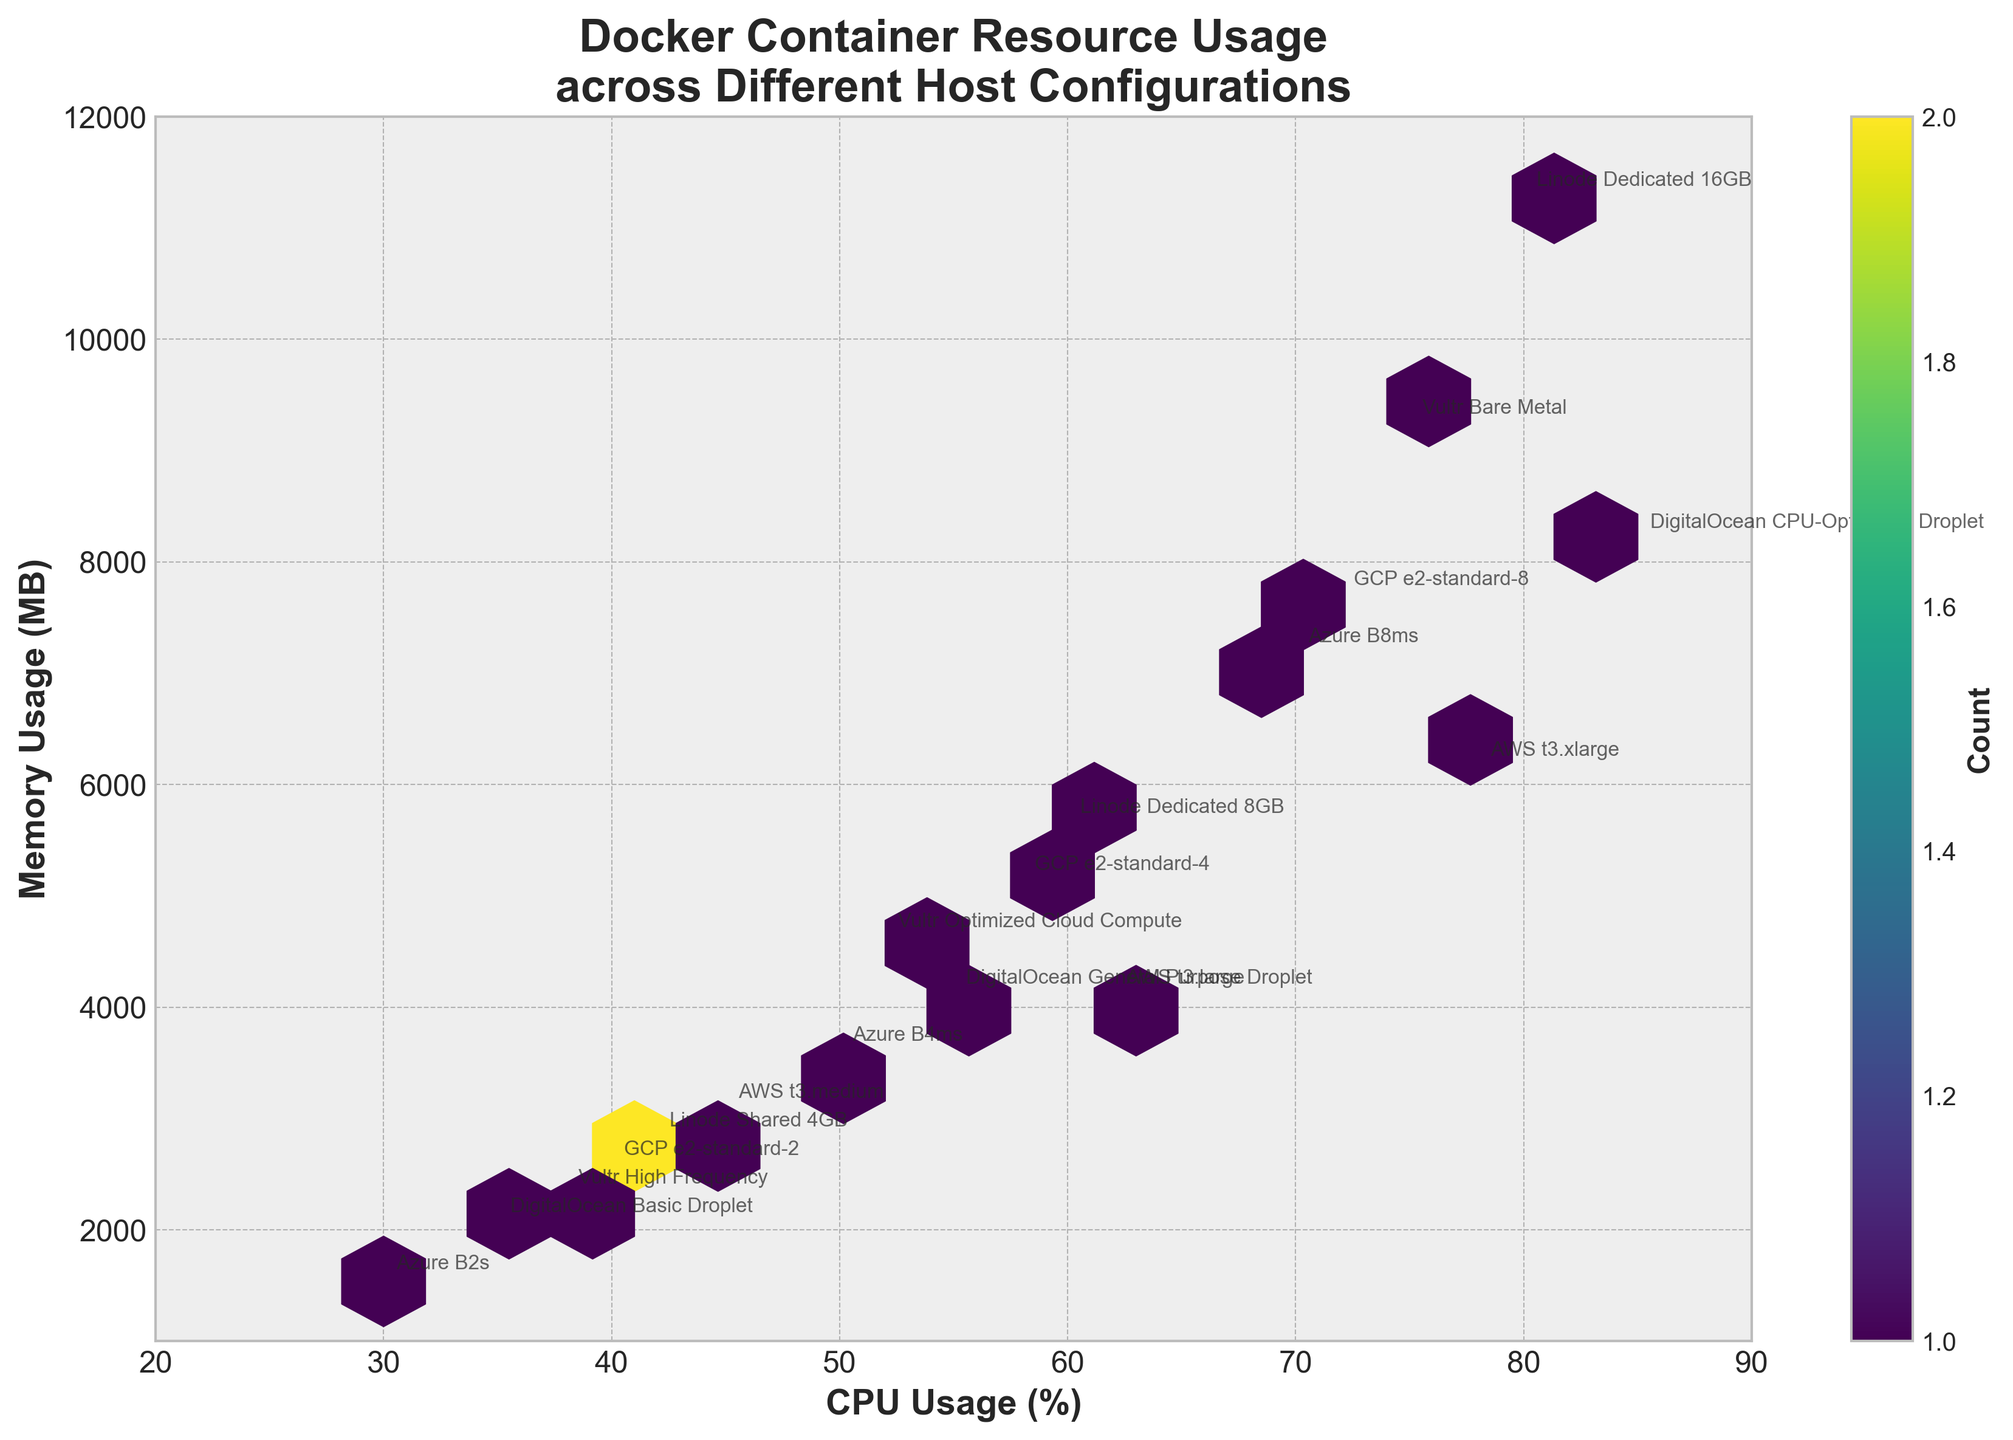What does the title of the hexbin plot indicate? The title of the hexbin plot, "Docker Container Resource Usage across Different Host Configurations," indicates that the plot shows the relationship between CPU usage and memory usage of Docker containers on various host configurations.
Answer: Docker Container Resource Usage across Different Host Configurations What are the labels of the x-axis and y-axis? The labels of the x-axis and y-axis convey the metrics being plotted. The x-axis is labeled "CPU Usage (%)" and represents the percentage of CPU used, while the y-axis is labeled "Memory Usage (MB)" and represents memory usage in megabytes.
Answer: CPU Usage (%) and Memory Usage (MB) How many hexagonal bins are shown in the plot? The "gridsize" parameter is set to 15, indicating that the plot has a hexagonal grid of 15 bins along each axis. However, the actual number of visible hexagons depends on the data distribution within those bins. Visually estimating or counting might be required for an exact number.
Answer: 15 along each axis Which host configuration has the highest CPU and memory usage? The host configuration with the highest CPU usage (85%) and memory usage (8192 MB) is 'DigitalOcean CPU-Optimized Droplet', as annotated on the plot at the upper right corner.
Answer: DigitalOcean CPU-Optimized Droplet How does CPU usage correlate with memory usage according to the plot? Observing the hexbin plot, there appears to be a positive correlation between CPU usage and memory usage: as the CPU usage increases, the memory usage also tends to increase. This is evident from the overall upward trend in the distribution of hexagonal bins.
Answer: Positive correlation Which host configuration has the lowest memory usage for a given CPU usage? To identify the host configuration with the lowest memory usage for a given CPU usage, we look for the point with the minimum y-axis value (memory usage) for the given x-axis value (CPU usage). As a detailed examination, 'Azure B2s' has relatively lower memory usage (1536 MB) at a CPU usage of 30%.
Answer: Azure B2s What is the color bar representing in the plot? The color bar represents the count of data points within each hexagonal bin. The more data points a bin contains, the darker its coloration according to the 'viridis' colormap used in the plot.
Answer: Count of data points How many data points are annotated with host configurations on the plot? By counting the number of different host configurations annotated on the plot, we find there are 17 data points, each corresponding to a unique host configuration listed in the data provided.
Answer: 17 data points 